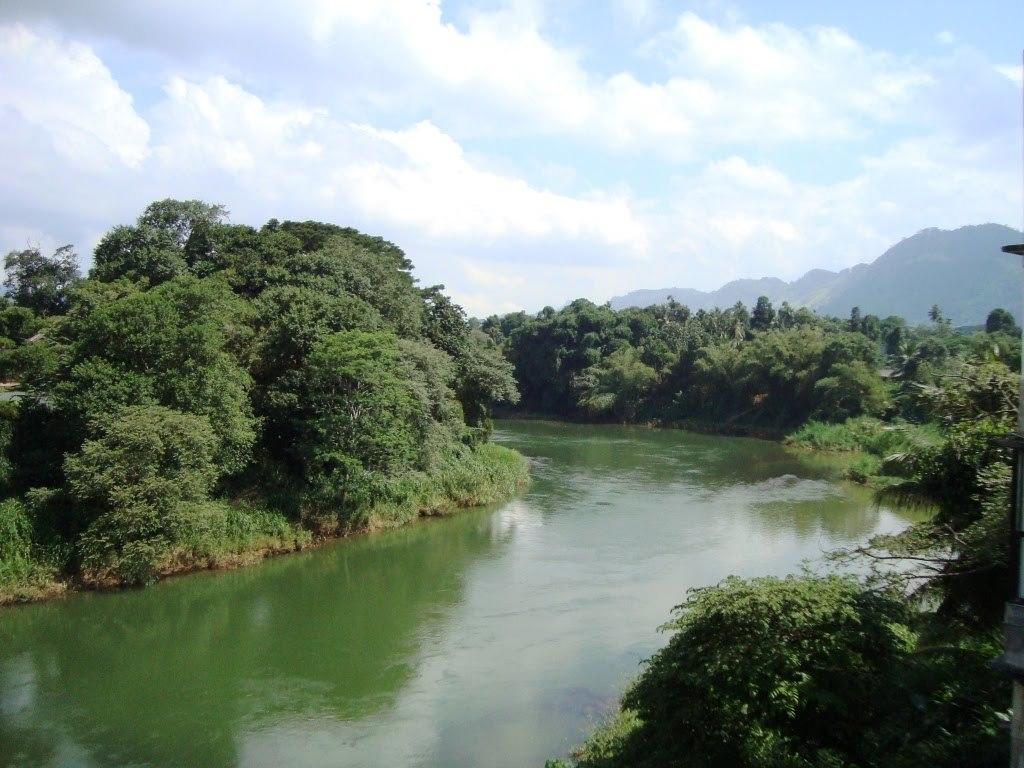What type of vegetation is located near the water in the image? There are trees beside the water in the image. What is the condition of the sky in the image? The sky is cloudy in the image. How many babies are visible in the image? There are no babies present in the image. What type of ghost can be seen interacting with the trees in the image? There is no ghost present in the image; only trees and water are visible. 